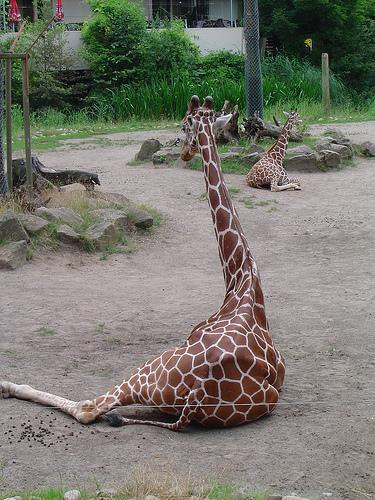Describe two distinct details about the trees in this image. There is a headless tree stump alongside the road, and tall bushes alongside a fence. Provide a short description of the ground in the image. The ground in the image is comprised of grey dirt, sparse green grass, and grey rocks and boulders. What type of furniture can you find on the porch in this image? There is patio furniture on the porch. What color combination does the umbrella have? The umbrella has a red and white color combination. What can you observe about the fence mentioned in the image? There is a grey chain-linked fence wrapped around a tree, and a tall tree trunk is protected by it. In what position are the two giraffes found in the image? The two giraffes are laying down on the ground. List the objects in the image that relate to a giraffe. Giraffe food on the ground, giraffe laying down in the dirt, back of giraffe's tail, baby giraffe resting on the ground, brown and white pattern on giraffe, two giraffes laying down, giraffe dung pellets on the ground, giraffe has a long erect neck, two giraffes in a pen, two giraffes laying on the ground, baby giraffe on ground, brown spots on animal, tail of the giraffe, neck of the giraffe, head of the giraffe, leg of the giraffe. Who might be a potential target audience for a product advertisement using this image? A potential target audience could be families with children, or animal enthusiasts interested in visiting a zoo or safari park. Comment on the appearance of the giraffe's droppings found on the ground. The giraffe's droppings on the ground look like small, brown raisin-like feces or dung pellets. Mention an object in the image that is growing from the rocks. Green grass is growing out of the rocks. 